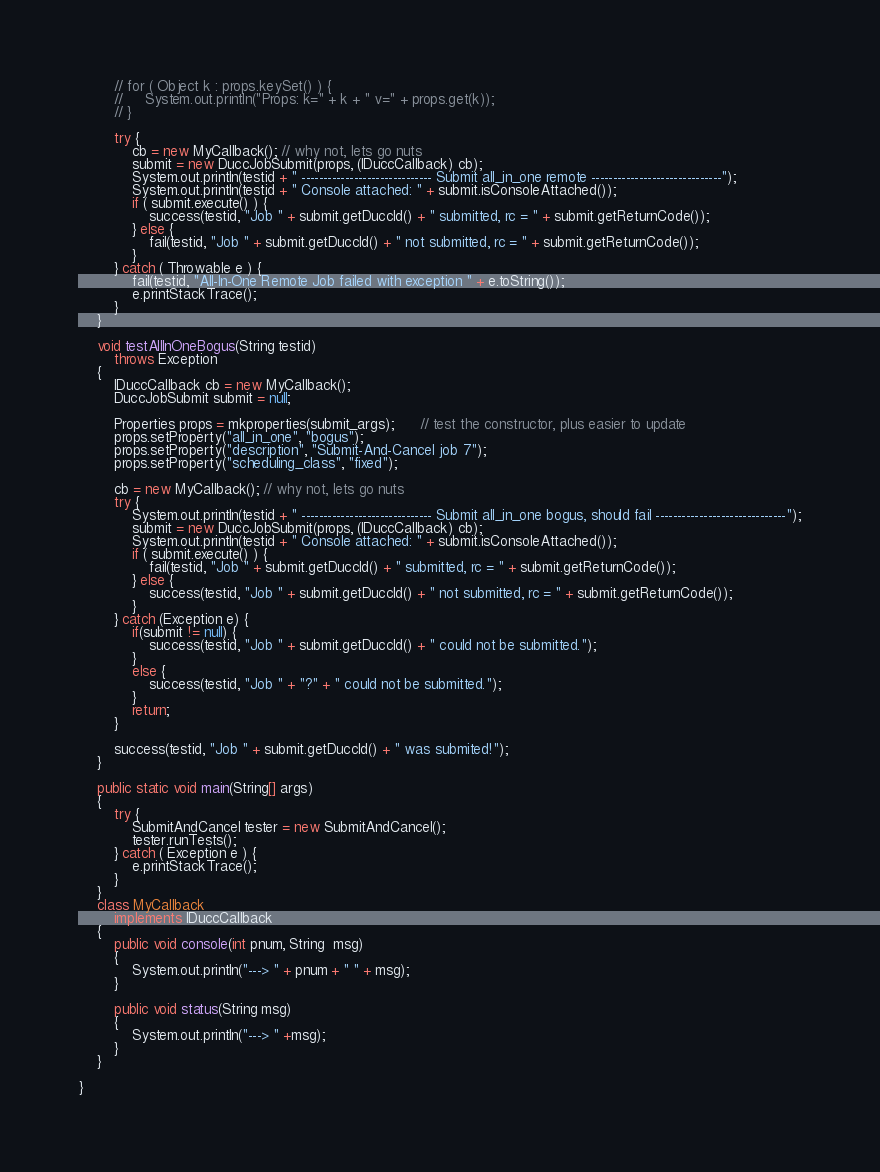Convert code to text. <code><loc_0><loc_0><loc_500><loc_500><_Java_>
        // for ( Object k : props.keySet() ) {
        //     System.out.println("Props: k=" + k + " v=" + props.get(k));
        // }

        try {
            cb = new MyCallback(); // why not, lets go nuts
            submit = new DuccJobSubmit(props, (IDuccCallback) cb);
            System.out.println(testid + " ------------------------------ Submit all_in_one remote ------------------------------");
            System.out.println(testid + " Console attached: " + submit.isConsoleAttached());
            if ( submit.execute() ) {
                success(testid, "Job " + submit.getDuccId() + " submitted, rc = " + submit.getReturnCode());
            } else {
                fail(testid, "Job " + submit.getDuccId() + " not submitted, rc = " + submit.getReturnCode());
            }
        } catch ( Throwable e ) {
            fail(testid, "All-In-One Remote Job failed with exception " + e.toString());
            e.printStackTrace();
        }
    }

    void testAllInOneBogus(String testid)
        throws Exception
    {
        IDuccCallback cb = new MyCallback();
        DuccJobSubmit submit = null;

        Properties props = mkproperties(submit_args);      // test the constructor, plus easier to update        
        props.setProperty("all_in_one", "bogus");
        props.setProperty("description", "Submit-And-Cancel job 7");
        props.setProperty("scheduling_class", "fixed");

        cb = new MyCallback(); // why not, lets go nuts
        try {
            System.out.println(testid + " ------------------------------ Submit all_in_one bogus, should fail ------------------------------");
            submit = new DuccJobSubmit(props, (IDuccCallback) cb);
            System.out.println(testid + " Console attached: " + submit.isConsoleAttached());
            if ( submit.execute() ) {
                fail(testid, "Job " + submit.getDuccId() + " submitted, rc = " + submit.getReturnCode());
            } else {
                success(testid, "Job " + submit.getDuccId() + " not submitted, rc = " + submit.getReturnCode());
            }
        } catch (Exception e) {
        	if(submit != null) {
        		success(testid, "Job " + submit.getDuccId() + " could not be submitted.");
        	}
        	else {
        		success(testid, "Job " + "?" + " could not be submitted.");
        	}
            return;
        }

        success(testid, "Job " + submit.getDuccId() + " was submited!");
    }
    
    public static void main(String[] args)
    {
        try {
            SubmitAndCancel tester = new SubmitAndCancel();
            tester.runTests();
        } catch ( Exception e ) {
            e.printStackTrace();
        }
    }
    class MyCallback
        implements IDuccCallback
    {
        public void console(int pnum, String  msg)
        {
            System.out.println("---> " + pnum + " " + msg);
        }

        public void status(String msg)
        {
            System.out.println("---> " +msg);
        }
    }

}
</code> 